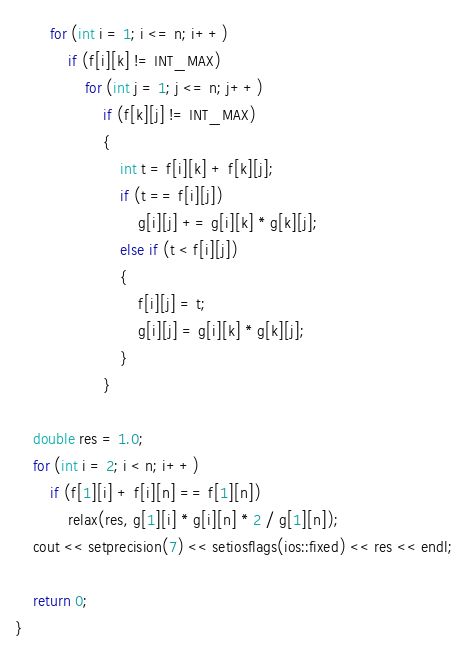<code> <loc_0><loc_0><loc_500><loc_500><_C++_>		for (int i = 1; i <= n; i++)
			if (f[i][k] != INT_MAX)
				for (int j = 1; j <= n; j++)
					if (f[k][j] != INT_MAX)
					{
						int t = f[i][k] + f[k][j];
						if (t == f[i][j])
							g[i][j] += g[i][k] * g[k][j];
						else if (t < f[i][j])
						{
							f[i][j] = t;
							g[i][j] = g[i][k] * g[k][j];
						}
					}
	
	double res = 1.0;
	for (int i = 2; i < n; i++)
		if (f[1][i] + f[i][n] == f[1][n])
			relax(res, g[1][i] * g[i][n] * 2 / g[1][n]);
	cout << setprecision(7) << setiosflags(ios::fixed) << res << endl;

	return 0;
}
</code> 